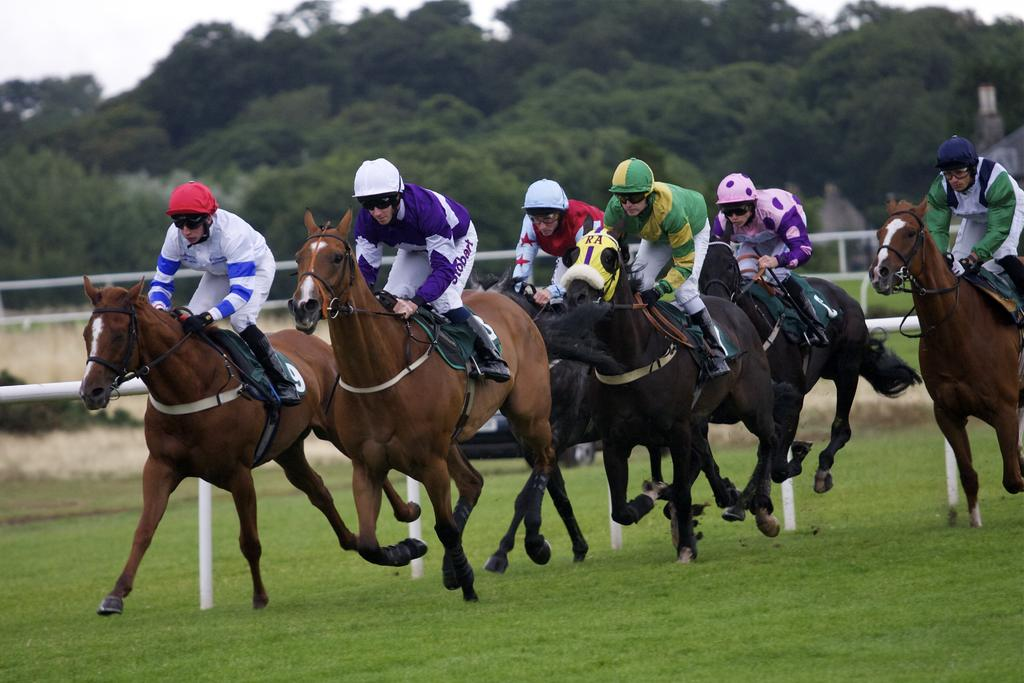What are the people in the image doing? The people in the image are riding horses. What type of terrain is visible at the bottom of the image? There is grass at the bottom of the image. What protective gear are the people wearing? The people are wearing helmets. What can be seen in the background of the image? There are trees in the background of the image. How many servants are visible in the image? There are no servants present in the image. What type of tent can be seen in the background of the image? There is no tent visible in the image; only trees are present in the background. 